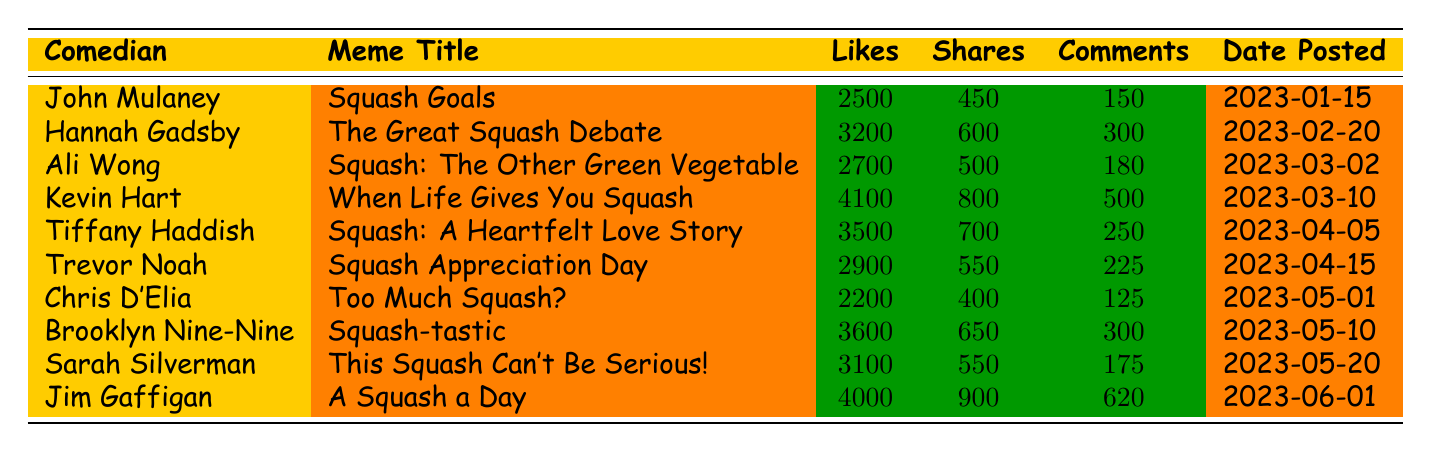What comedian had the most likes on their meme post? Looking at the 'likes' column, Kevin Hart has the highest value with 4100 likes.
Answer: Kevin Hart What was the title of the meme posted by Jim Gaffigan? By scanning the 'comedian' column for Jim Gaffigan, the corresponding 'meme title' is "A Squash a Day".
Answer: A Squash a Day How many total shares did the memes from Tiffany Haddish and Trevor Noah receive? Tiffany Haddish has 700 shares and Trevor Noah has 550 shares. Adding these gives 700 + 550 = 1250 shares total.
Answer: 1250 Did Chris D'Elia’s meme receive more comments than Sarah Silverman's? Chris D'Elia received 125 comments while Sarah Silverman received 175. Since 125 is less than 175, the answer is no.
Answer: No What is the average number of likes for all the meme posts? To find the average, sum the likes: 2500 + 3200 + 2700 + 4100 + 3500 + 2900 + 2200 + 3600 + 3100 + 4000 = 30000. There are 10 meme posts, so the average is 30000 / 10 = 3000.
Answer: 3000 Which meme title has the least number of shares? By comparing the 'shares' column, Chris D'Elia's meme titled "Too Much Squash?" has the least with 400 shares.
Answer: Too Much Squash? How many comedians had more than 300 comments on their meme posts? By checking the 'comments' column, Kevin Hart, Tiffany Haddish, and Jim Gaffigan have 500, 250, and 620 comments respectively. Therefore, only Kevin Hart and Jim Gaffigan exceed 300 comments, making it 2 comedians.
Answer: 2 Was the meme titled "Squash: A Heartfelt Love Story" posted before "Squash Appreciation Day"? "Squash: A Heartfelt Love Story" was posted on 2023-04-05, while "Squash Appreciation Day" was posted on 2023-04-15. Since 2023-04-05 is before 2023-04-15, the answer is yes.
Answer: Yes What is the total of likes for memes posted in March? Only three memes were posted in March: Ali Wong (2700), Kevin Hart (4100), and a meme shared by D'Elia later in the month. Summing these values gives 2700 + 4100 + 0 = 6800. However, only the first two are in March. Thus, the correct total is 2700 + 4100 = 6800.
Answer: 6800 